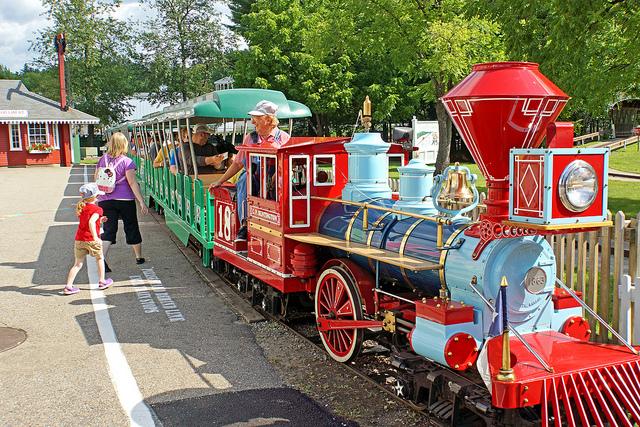How many people are headed towards the train?
Quick response, please. 2. Can you ride the train?
Short answer required. Yes. Are the people in an amusement park?
Concise answer only. Yes. 